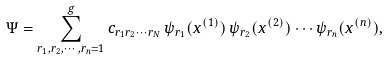<formula> <loc_0><loc_0><loc_500><loc_500>\Psi = \sum _ { r _ { 1 } , r _ { 2 } , \cdots , r _ { n } = 1 } ^ { g } c _ { r _ { 1 } r _ { 2 } \cdots r _ { N } } \, \psi _ { r _ { 1 } } ( x ^ { ( 1 ) } ) \, \psi _ { r _ { 2 } } ( x ^ { ( 2 ) } ) \cdots \psi _ { r _ { n } } ( x ^ { ( n ) } ) ,</formula> 